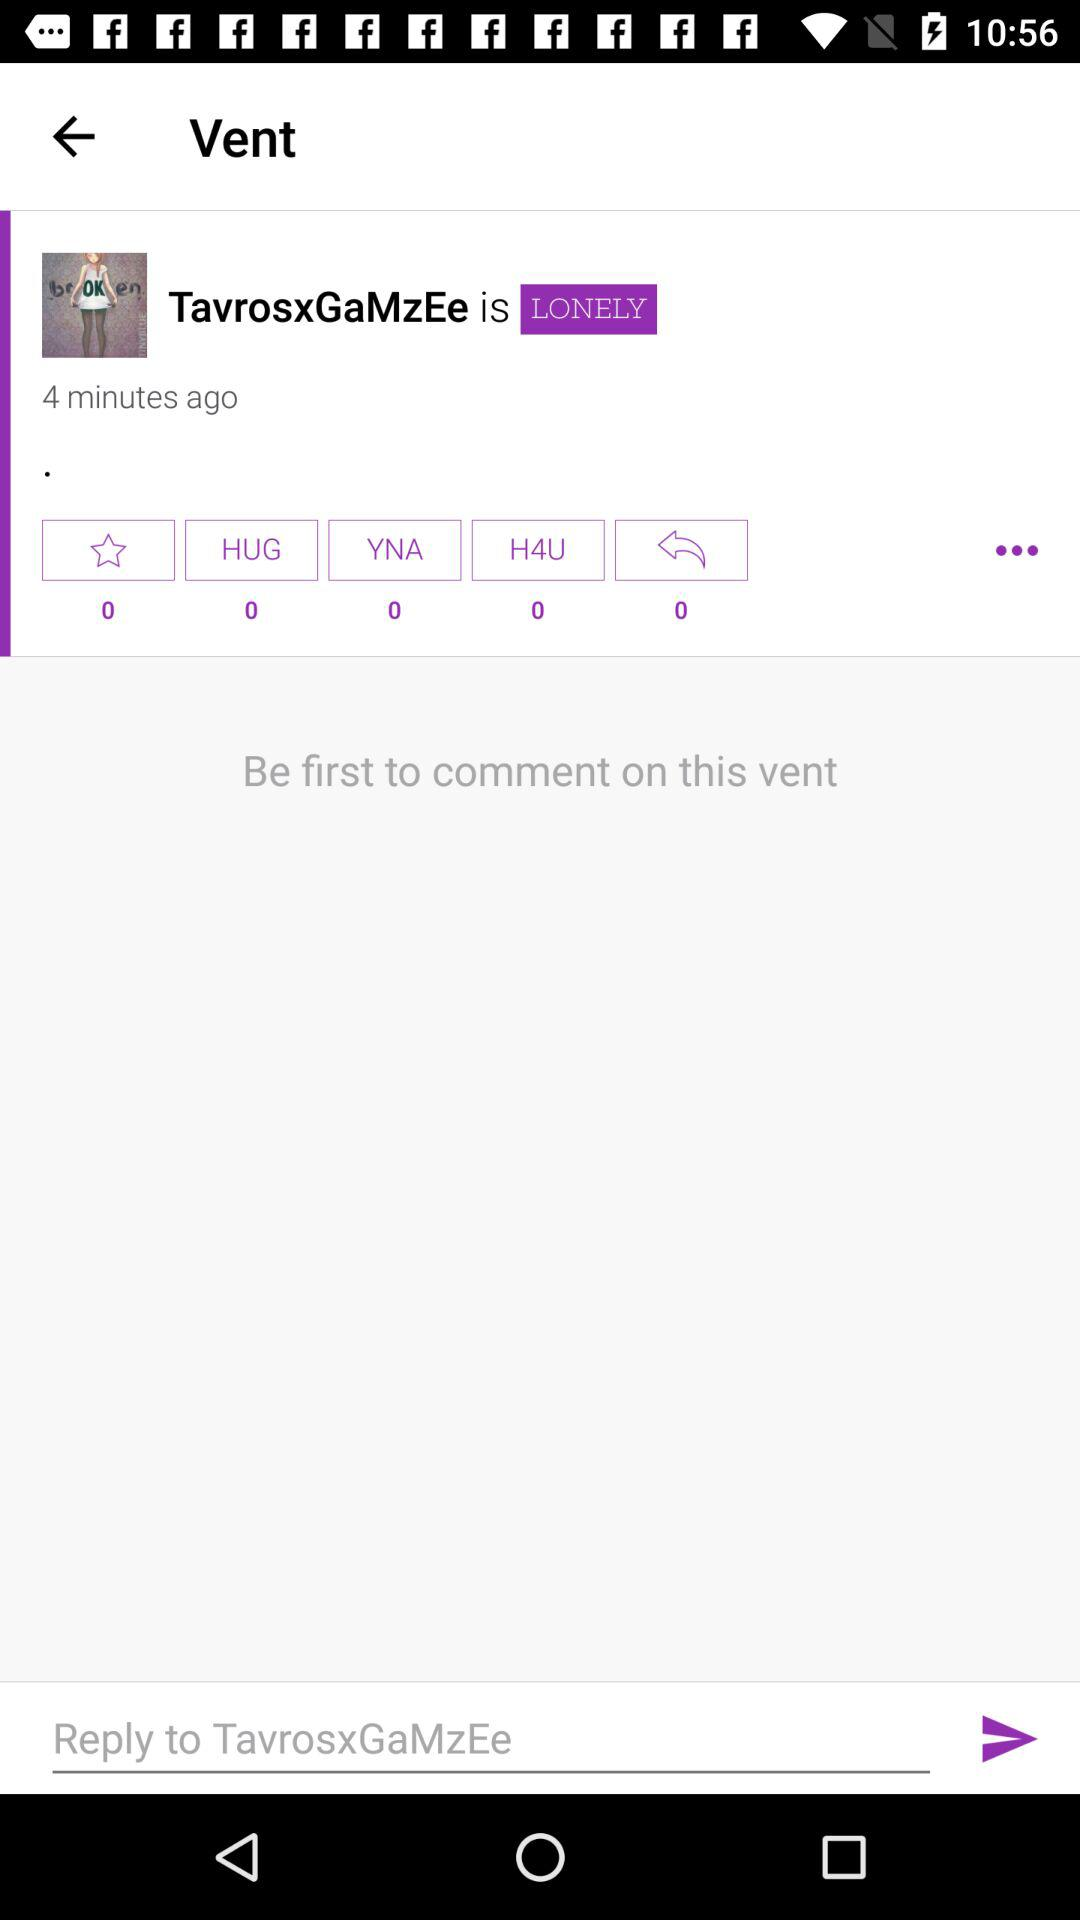When did "TavrosxGaMzEe" post on the "Vent"? "TavrosxGaMzEe" posted 4 minutes ago. 